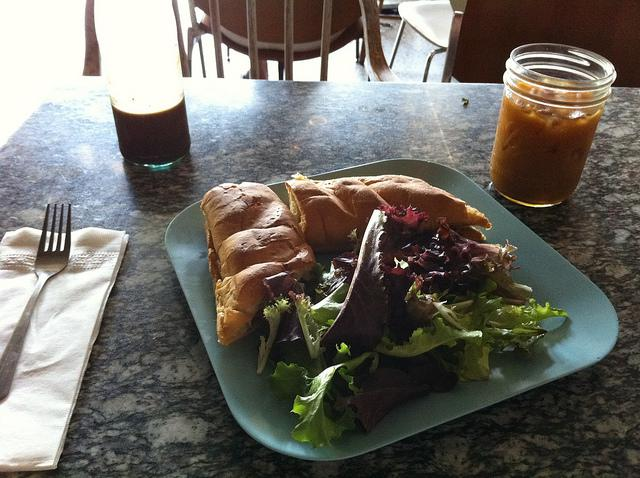What type of drink in in the jar?

Choices:
A) wine
B) coke
C) 7-up
D) iced coffee iced coffee 